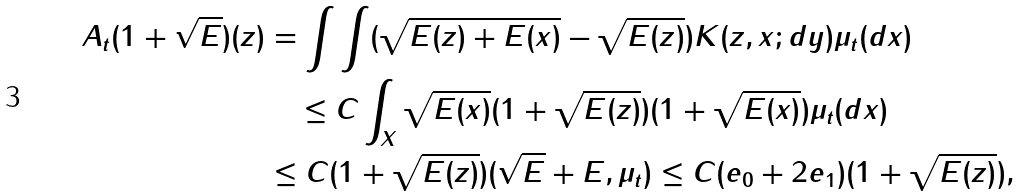Convert formula to latex. <formula><loc_0><loc_0><loc_500><loc_500>A _ { t } ( 1 + \sqrt { E } ) ( z ) & = \int \int ( \sqrt { E ( z ) + E ( x ) } - \sqrt { E ( z ) } ) K ( z , x ; d y ) \mu _ { t } ( d x ) \\ & \quad \leq C \int _ { X } \sqrt { E ( x ) } ( 1 + \sqrt { E ( z ) } ) ( 1 + \sqrt { E ( x ) } ) \mu _ { t } ( d x ) \\ & \leq C ( 1 + \sqrt { E ( z ) } ) ( \sqrt { E } + E , \mu _ { t } ) \leq C ( e _ { 0 } + 2 e _ { 1 } ) ( 1 + \sqrt { E ( z ) } ) ,</formula> 